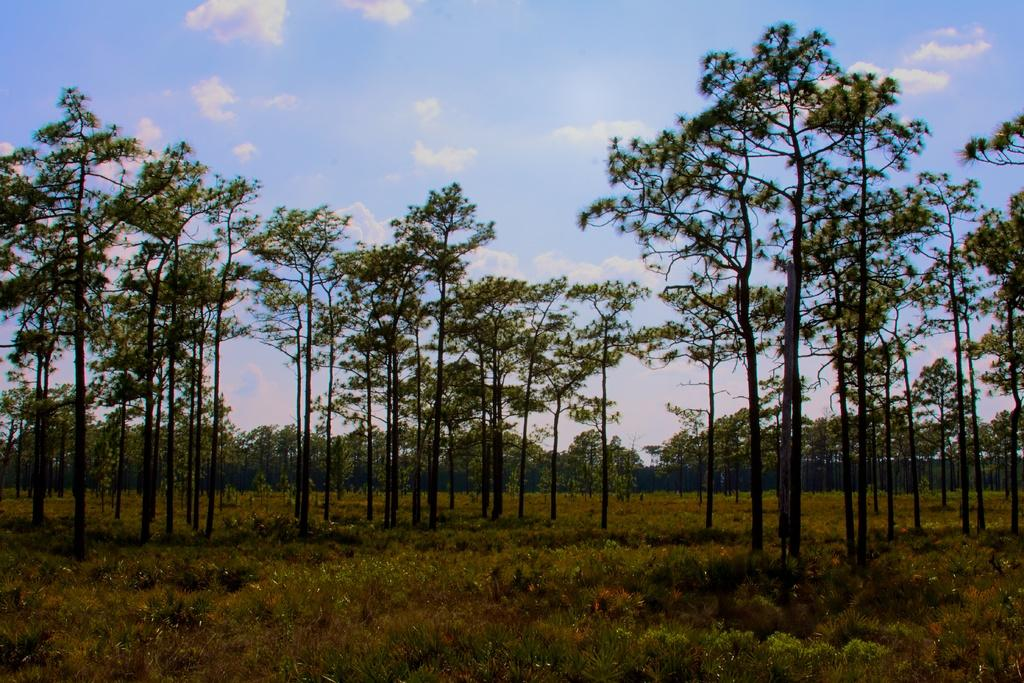What type of vegetation can be seen in the image? There is grass, plants, and trees in the image. What part of the natural environment is visible in the image? The sky is visible in the background of the image. What type of polish is being applied to the wrist in the image? There is no wrist or polish present in the image; it features grass, plants, trees, and the sky. 